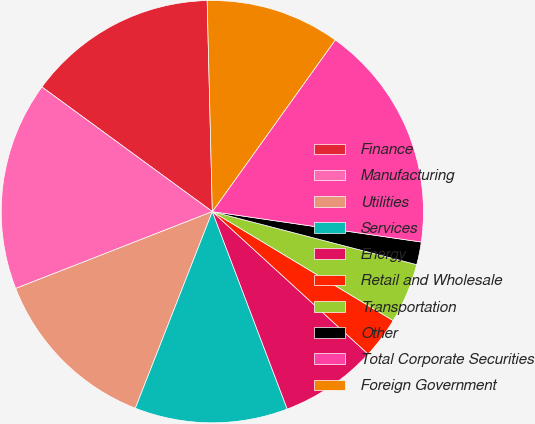Convert chart to OTSL. <chart><loc_0><loc_0><loc_500><loc_500><pie_chart><fcel>Finance<fcel>Manufacturing<fcel>Utilities<fcel>Services<fcel>Energy<fcel>Retail and Wholesale<fcel>Transportation<fcel>Other<fcel>Total Corporate Securities<fcel>Foreign Government<nl><fcel>14.56%<fcel>15.98%<fcel>13.13%<fcel>11.71%<fcel>7.44%<fcel>3.16%<fcel>4.59%<fcel>1.74%<fcel>17.41%<fcel>10.28%<nl></chart> 